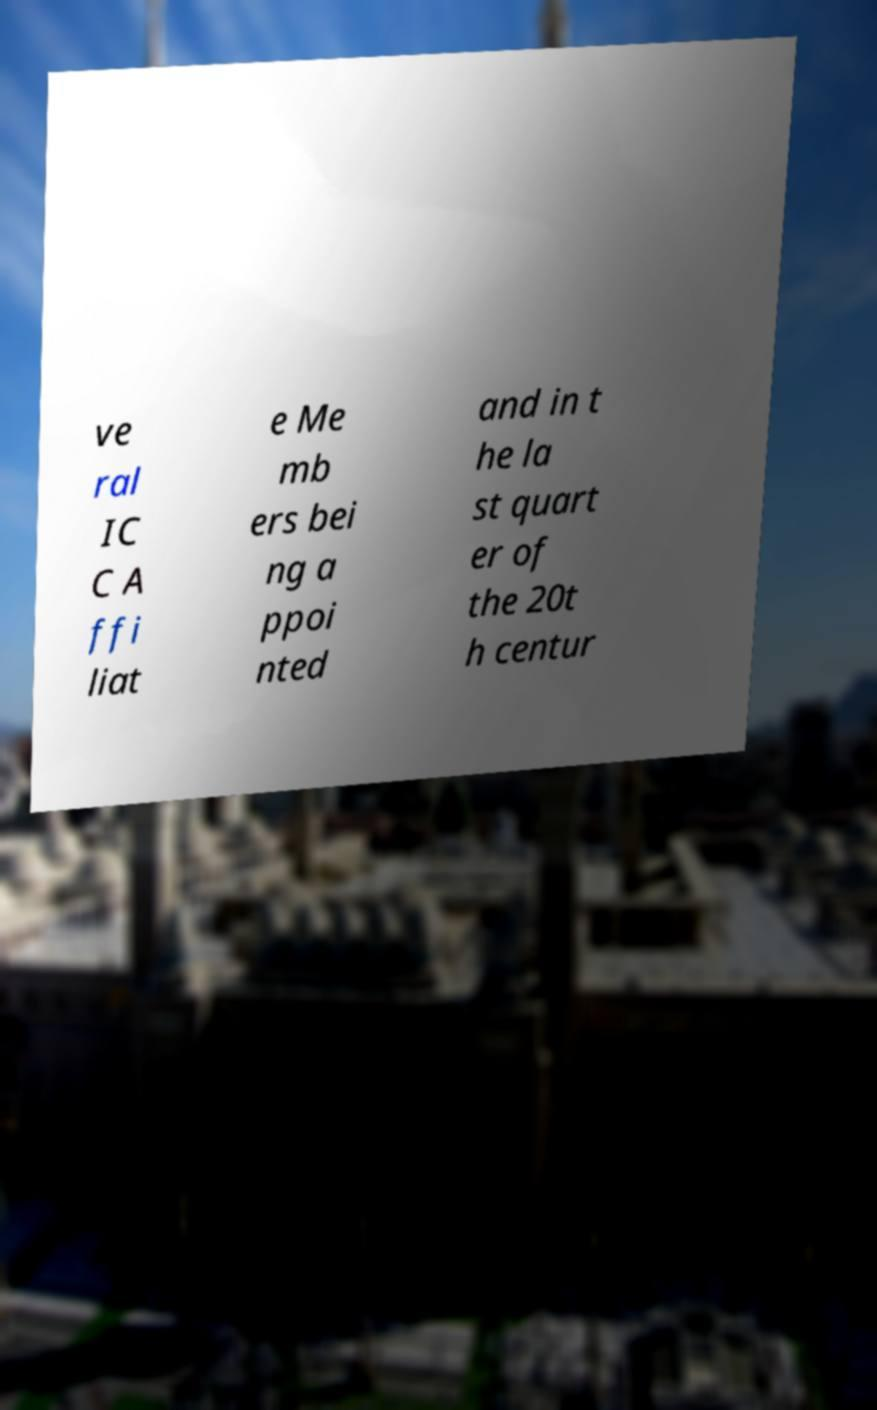Could you assist in decoding the text presented in this image and type it out clearly? ve ral IC C A ffi liat e Me mb ers bei ng a ppoi nted and in t he la st quart er of the 20t h centur 